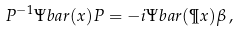Convert formula to latex. <formula><loc_0><loc_0><loc_500><loc_500>P ^ { - 1 } \Psi b a r ( x ) P = - i \Psi b a r ( \P x ) \beta \, ,</formula> 